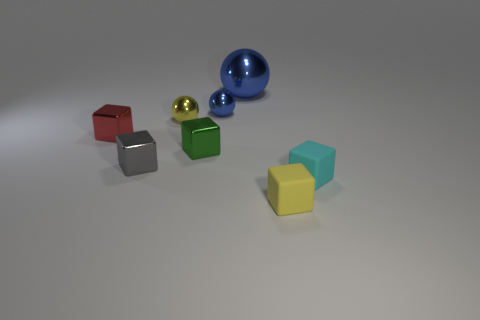Subtract all yellow rubber cubes. How many cubes are left? 4 Subtract all brown cubes. Subtract all cyan balls. How many cubes are left? 5 Add 1 spheres. How many objects exist? 9 Subtract all balls. How many objects are left? 5 Subtract 1 yellow cubes. How many objects are left? 7 Subtract all tiny things. Subtract all big rubber spheres. How many objects are left? 1 Add 4 shiny balls. How many shiny balls are left? 7 Add 5 tiny red objects. How many tiny red objects exist? 6 